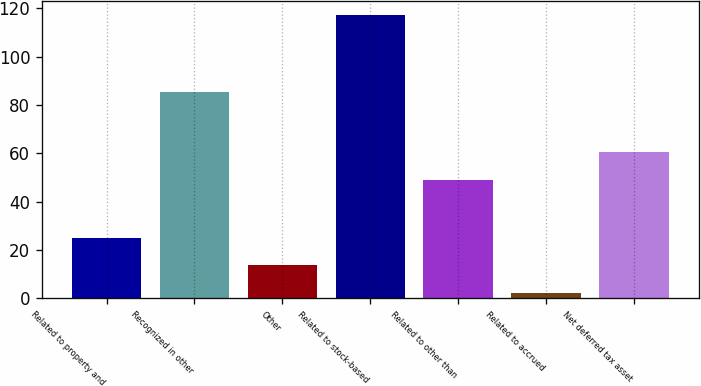<chart> <loc_0><loc_0><loc_500><loc_500><bar_chart><fcel>Related to property and<fcel>Recognized in other<fcel>Other<fcel>Related to stock-based<fcel>Related to other than<fcel>Related to accrued<fcel>Net deferred tax asset<nl><fcel>25.2<fcel>85.5<fcel>13.7<fcel>117.2<fcel>49.2<fcel>2.2<fcel>60.7<nl></chart> 